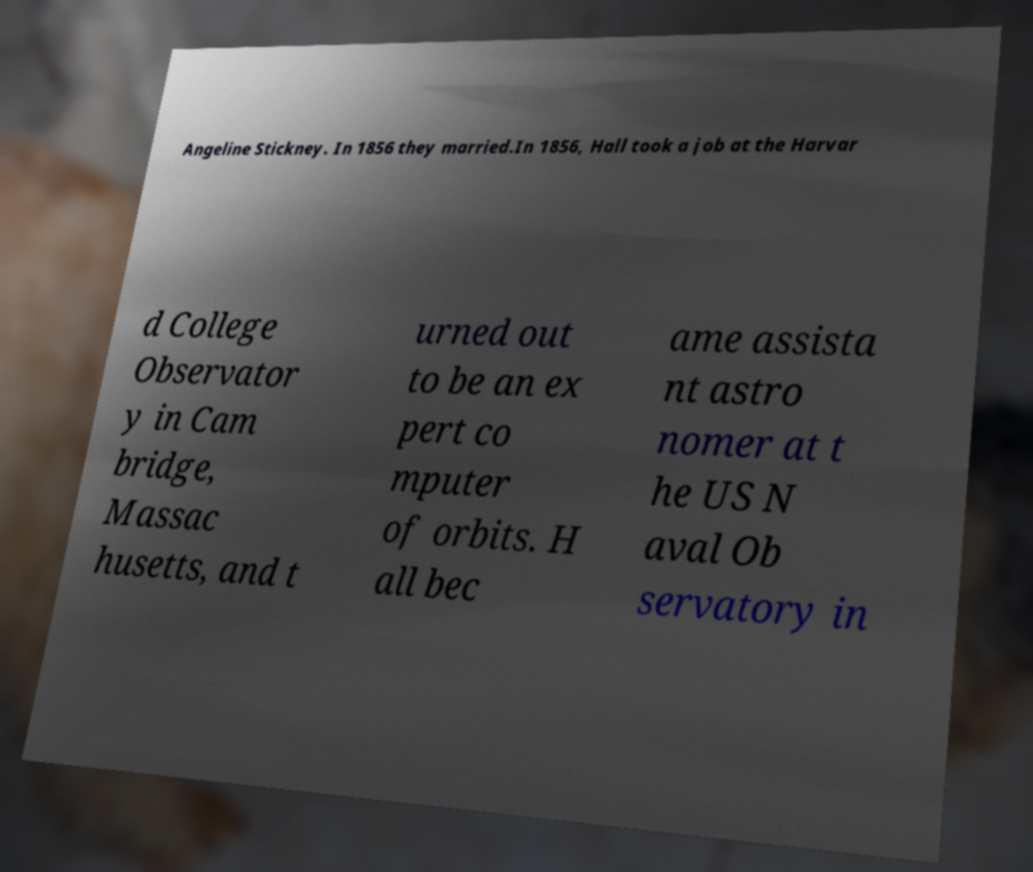Please read and relay the text visible in this image. What does it say? Angeline Stickney. In 1856 they married.In 1856, Hall took a job at the Harvar d College Observator y in Cam bridge, Massac husetts, and t urned out to be an ex pert co mputer of orbits. H all bec ame assista nt astro nomer at t he US N aval Ob servatory in 